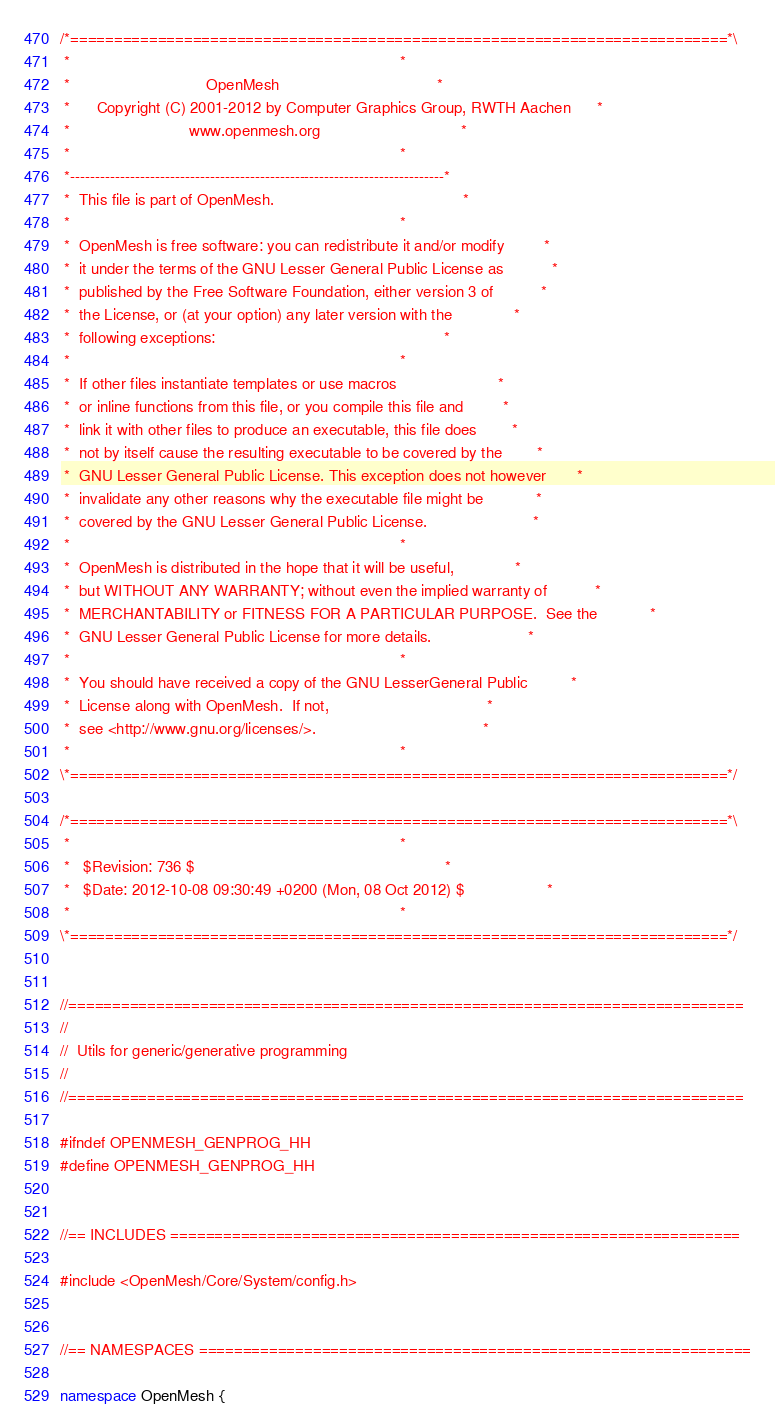Convert code to text. <code><loc_0><loc_0><loc_500><loc_500><_C++_>/*===========================================================================*\
 *                                                                           *
 *                               OpenMesh                                    *
 *      Copyright (C) 2001-2012 by Computer Graphics Group, RWTH Aachen      *
 *                           www.openmesh.org                                *
 *                                                                           *
 *---------------------------------------------------------------------------* 
 *  This file is part of OpenMesh.                                           *
 *                                                                           *
 *  OpenMesh is free software: you can redistribute it and/or modify         * 
 *  it under the terms of the GNU Lesser General Public License as           *
 *  published by the Free Software Foundation, either version 3 of           *
 *  the License, or (at your option) any later version with the              *
 *  following exceptions:                                                    *
 *                                                                           *
 *  If other files instantiate templates or use macros                       *
 *  or inline functions from this file, or you compile this file and         *
 *  link it with other files to produce an executable, this file does        *
 *  not by itself cause the resulting executable to be covered by the        *
 *  GNU Lesser General Public License. This exception does not however       *
 *  invalidate any other reasons why the executable file might be            *
 *  covered by the GNU Lesser General Public License.                        *
 *                                                                           *
 *  OpenMesh is distributed in the hope that it will be useful,              *
 *  but WITHOUT ANY WARRANTY; without even the implied warranty of           *
 *  MERCHANTABILITY or FITNESS FOR A PARTICULAR PURPOSE.  See the            *
 *  GNU Lesser General Public License for more details.                      *
 *                                                                           *
 *  You should have received a copy of the GNU LesserGeneral Public          *
 *  License along with OpenMesh.  If not,                                    *
 *  see <http://www.gnu.org/licenses/>.                                      *
 *                                                                           *
\*===========================================================================*/ 

/*===========================================================================*\
 *                                                                           *             
 *   $Revision: 736 $                                                         *
 *   $Date: 2012-10-08 09:30:49 +0200 (Mon, 08 Oct 2012) $                   *
 *                                                                           *
\*===========================================================================*/


//=============================================================================
//
//  Utils for generic/generative programming
//
//=============================================================================

#ifndef OPENMESH_GENPROG_HH
#define OPENMESH_GENPROG_HH


//== INCLUDES =================================================================

#include <OpenMesh/Core/System/config.h>


//== NAMESPACES ===============================================================

namespace OpenMesh {
</code> 